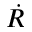Convert formula to latex. <formula><loc_0><loc_0><loc_500><loc_500>\dot { R }</formula> 